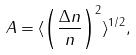<formula> <loc_0><loc_0><loc_500><loc_500>A = \langle \left ( \frac { \Delta n } { n } \right ) ^ { 2 } \rangle ^ { 1 / 2 } ,</formula> 